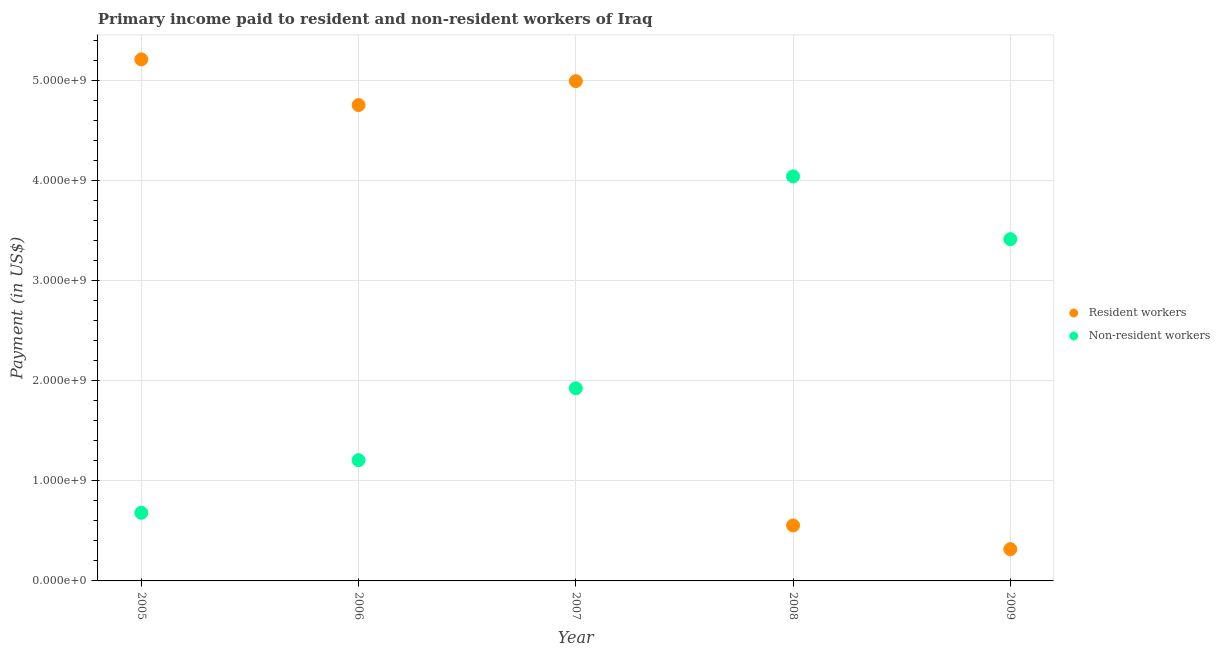Is the number of dotlines equal to the number of legend labels?
Keep it short and to the point. Yes. What is the payment made to resident workers in 2009?
Make the answer very short. 3.17e+08. Across all years, what is the maximum payment made to non-resident workers?
Offer a terse response. 4.04e+09. Across all years, what is the minimum payment made to non-resident workers?
Your answer should be compact. 6.80e+08. In which year was the payment made to resident workers minimum?
Offer a terse response. 2009. What is the total payment made to resident workers in the graph?
Your answer should be very brief. 1.58e+1. What is the difference between the payment made to resident workers in 2006 and that in 2008?
Ensure brevity in your answer.  4.20e+09. What is the difference between the payment made to non-resident workers in 2006 and the payment made to resident workers in 2009?
Ensure brevity in your answer.  8.88e+08. What is the average payment made to resident workers per year?
Make the answer very short. 3.16e+09. In the year 2009, what is the difference between the payment made to resident workers and payment made to non-resident workers?
Provide a succinct answer. -3.10e+09. What is the ratio of the payment made to non-resident workers in 2007 to that in 2008?
Provide a succinct answer. 0.48. What is the difference between the highest and the second highest payment made to resident workers?
Provide a short and direct response. 2.17e+08. What is the difference between the highest and the lowest payment made to non-resident workers?
Ensure brevity in your answer.  3.36e+09. Is the payment made to non-resident workers strictly greater than the payment made to resident workers over the years?
Offer a terse response. No. Is the payment made to non-resident workers strictly less than the payment made to resident workers over the years?
Your answer should be compact. No. Are the values on the major ticks of Y-axis written in scientific E-notation?
Offer a terse response. Yes. How are the legend labels stacked?
Your answer should be compact. Vertical. What is the title of the graph?
Offer a terse response. Primary income paid to resident and non-resident workers of Iraq. Does "RDB concessional" appear as one of the legend labels in the graph?
Offer a terse response. No. What is the label or title of the X-axis?
Provide a short and direct response. Year. What is the label or title of the Y-axis?
Keep it short and to the point. Payment (in US$). What is the Payment (in US$) in Resident workers in 2005?
Your answer should be compact. 5.21e+09. What is the Payment (in US$) of Non-resident workers in 2005?
Provide a short and direct response. 6.80e+08. What is the Payment (in US$) of Resident workers in 2006?
Give a very brief answer. 4.75e+09. What is the Payment (in US$) in Non-resident workers in 2006?
Offer a very short reply. 1.21e+09. What is the Payment (in US$) in Resident workers in 2007?
Offer a terse response. 4.99e+09. What is the Payment (in US$) in Non-resident workers in 2007?
Provide a succinct answer. 1.92e+09. What is the Payment (in US$) of Resident workers in 2008?
Provide a short and direct response. 5.54e+08. What is the Payment (in US$) of Non-resident workers in 2008?
Keep it short and to the point. 4.04e+09. What is the Payment (in US$) in Resident workers in 2009?
Provide a succinct answer. 3.17e+08. What is the Payment (in US$) of Non-resident workers in 2009?
Ensure brevity in your answer.  3.41e+09. Across all years, what is the maximum Payment (in US$) in Resident workers?
Your answer should be compact. 5.21e+09. Across all years, what is the maximum Payment (in US$) in Non-resident workers?
Your response must be concise. 4.04e+09. Across all years, what is the minimum Payment (in US$) in Resident workers?
Provide a succinct answer. 3.17e+08. Across all years, what is the minimum Payment (in US$) of Non-resident workers?
Offer a terse response. 6.80e+08. What is the total Payment (in US$) in Resident workers in the graph?
Your answer should be very brief. 1.58e+1. What is the total Payment (in US$) in Non-resident workers in the graph?
Your response must be concise. 1.13e+1. What is the difference between the Payment (in US$) in Resident workers in 2005 and that in 2006?
Keep it short and to the point. 4.56e+08. What is the difference between the Payment (in US$) of Non-resident workers in 2005 and that in 2006?
Your answer should be compact. -5.25e+08. What is the difference between the Payment (in US$) of Resident workers in 2005 and that in 2007?
Provide a succinct answer. 2.17e+08. What is the difference between the Payment (in US$) in Non-resident workers in 2005 and that in 2007?
Provide a succinct answer. -1.24e+09. What is the difference between the Payment (in US$) in Resident workers in 2005 and that in 2008?
Keep it short and to the point. 4.65e+09. What is the difference between the Payment (in US$) in Non-resident workers in 2005 and that in 2008?
Your answer should be very brief. -3.36e+09. What is the difference between the Payment (in US$) of Resident workers in 2005 and that in 2009?
Ensure brevity in your answer.  4.89e+09. What is the difference between the Payment (in US$) of Non-resident workers in 2005 and that in 2009?
Your answer should be compact. -2.73e+09. What is the difference between the Payment (in US$) of Resident workers in 2006 and that in 2007?
Give a very brief answer. -2.39e+08. What is the difference between the Payment (in US$) in Non-resident workers in 2006 and that in 2007?
Offer a terse response. -7.18e+08. What is the difference between the Payment (in US$) of Resident workers in 2006 and that in 2008?
Keep it short and to the point. 4.20e+09. What is the difference between the Payment (in US$) of Non-resident workers in 2006 and that in 2008?
Ensure brevity in your answer.  -2.83e+09. What is the difference between the Payment (in US$) in Resident workers in 2006 and that in 2009?
Your answer should be very brief. 4.43e+09. What is the difference between the Payment (in US$) in Non-resident workers in 2006 and that in 2009?
Give a very brief answer. -2.21e+09. What is the difference between the Payment (in US$) in Resident workers in 2007 and that in 2008?
Offer a very short reply. 4.44e+09. What is the difference between the Payment (in US$) in Non-resident workers in 2007 and that in 2008?
Give a very brief answer. -2.12e+09. What is the difference between the Payment (in US$) in Resident workers in 2007 and that in 2009?
Keep it short and to the point. 4.67e+09. What is the difference between the Payment (in US$) in Non-resident workers in 2007 and that in 2009?
Offer a very short reply. -1.49e+09. What is the difference between the Payment (in US$) of Resident workers in 2008 and that in 2009?
Ensure brevity in your answer.  2.36e+08. What is the difference between the Payment (in US$) of Non-resident workers in 2008 and that in 2009?
Provide a short and direct response. 6.27e+08. What is the difference between the Payment (in US$) in Resident workers in 2005 and the Payment (in US$) in Non-resident workers in 2006?
Give a very brief answer. 4.00e+09. What is the difference between the Payment (in US$) of Resident workers in 2005 and the Payment (in US$) of Non-resident workers in 2007?
Provide a succinct answer. 3.28e+09. What is the difference between the Payment (in US$) of Resident workers in 2005 and the Payment (in US$) of Non-resident workers in 2008?
Keep it short and to the point. 1.17e+09. What is the difference between the Payment (in US$) of Resident workers in 2005 and the Payment (in US$) of Non-resident workers in 2009?
Your answer should be very brief. 1.80e+09. What is the difference between the Payment (in US$) of Resident workers in 2006 and the Payment (in US$) of Non-resident workers in 2007?
Give a very brief answer. 2.83e+09. What is the difference between the Payment (in US$) of Resident workers in 2006 and the Payment (in US$) of Non-resident workers in 2008?
Offer a terse response. 7.12e+08. What is the difference between the Payment (in US$) of Resident workers in 2006 and the Payment (in US$) of Non-resident workers in 2009?
Ensure brevity in your answer.  1.34e+09. What is the difference between the Payment (in US$) of Resident workers in 2007 and the Payment (in US$) of Non-resident workers in 2008?
Give a very brief answer. 9.52e+08. What is the difference between the Payment (in US$) of Resident workers in 2007 and the Payment (in US$) of Non-resident workers in 2009?
Make the answer very short. 1.58e+09. What is the difference between the Payment (in US$) in Resident workers in 2008 and the Payment (in US$) in Non-resident workers in 2009?
Offer a very short reply. -2.86e+09. What is the average Payment (in US$) of Resident workers per year?
Make the answer very short. 3.16e+09. What is the average Payment (in US$) in Non-resident workers per year?
Your response must be concise. 2.25e+09. In the year 2005, what is the difference between the Payment (in US$) of Resident workers and Payment (in US$) of Non-resident workers?
Provide a succinct answer. 4.53e+09. In the year 2006, what is the difference between the Payment (in US$) of Resident workers and Payment (in US$) of Non-resident workers?
Keep it short and to the point. 3.55e+09. In the year 2007, what is the difference between the Payment (in US$) in Resident workers and Payment (in US$) in Non-resident workers?
Offer a very short reply. 3.07e+09. In the year 2008, what is the difference between the Payment (in US$) of Resident workers and Payment (in US$) of Non-resident workers?
Provide a succinct answer. -3.49e+09. In the year 2009, what is the difference between the Payment (in US$) in Resident workers and Payment (in US$) in Non-resident workers?
Keep it short and to the point. -3.10e+09. What is the ratio of the Payment (in US$) in Resident workers in 2005 to that in 2006?
Your answer should be compact. 1.1. What is the ratio of the Payment (in US$) in Non-resident workers in 2005 to that in 2006?
Your answer should be compact. 0.56. What is the ratio of the Payment (in US$) of Resident workers in 2005 to that in 2007?
Ensure brevity in your answer.  1.04. What is the ratio of the Payment (in US$) of Non-resident workers in 2005 to that in 2007?
Offer a terse response. 0.35. What is the ratio of the Payment (in US$) in Resident workers in 2005 to that in 2008?
Provide a short and direct response. 9.41. What is the ratio of the Payment (in US$) in Non-resident workers in 2005 to that in 2008?
Make the answer very short. 0.17. What is the ratio of the Payment (in US$) of Resident workers in 2005 to that in 2009?
Your response must be concise. 16.42. What is the ratio of the Payment (in US$) in Non-resident workers in 2005 to that in 2009?
Give a very brief answer. 0.2. What is the ratio of the Payment (in US$) in Non-resident workers in 2006 to that in 2007?
Your answer should be compact. 0.63. What is the ratio of the Payment (in US$) of Resident workers in 2006 to that in 2008?
Provide a short and direct response. 8.58. What is the ratio of the Payment (in US$) of Non-resident workers in 2006 to that in 2008?
Your answer should be compact. 0.3. What is the ratio of the Payment (in US$) of Resident workers in 2006 to that in 2009?
Your answer should be compact. 14.98. What is the ratio of the Payment (in US$) of Non-resident workers in 2006 to that in 2009?
Make the answer very short. 0.35. What is the ratio of the Payment (in US$) in Resident workers in 2007 to that in 2008?
Offer a very short reply. 9.01. What is the ratio of the Payment (in US$) of Non-resident workers in 2007 to that in 2008?
Your answer should be very brief. 0.48. What is the ratio of the Payment (in US$) in Resident workers in 2007 to that in 2009?
Offer a terse response. 15.74. What is the ratio of the Payment (in US$) in Non-resident workers in 2007 to that in 2009?
Provide a short and direct response. 0.56. What is the ratio of the Payment (in US$) in Resident workers in 2008 to that in 2009?
Give a very brief answer. 1.75. What is the ratio of the Payment (in US$) of Non-resident workers in 2008 to that in 2009?
Provide a short and direct response. 1.18. What is the difference between the highest and the second highest Payment (in US$) of Resident workers?
Provide a short and direct response. 2.17e+08. What is the difference between the highest and the second highest Payment (in US$) in Non-resident workers?
Provide a succinct answer. 6.27e+08. What is the difference between the highest and the lowest Payment (in US$) of Resident workers?
Provide a succinct answer. 4.89e+09. What is the difference between the highest and the lowest Payment (in US$) in Non-resident workers?
Keep it short and to the point. 3.36e+09. 